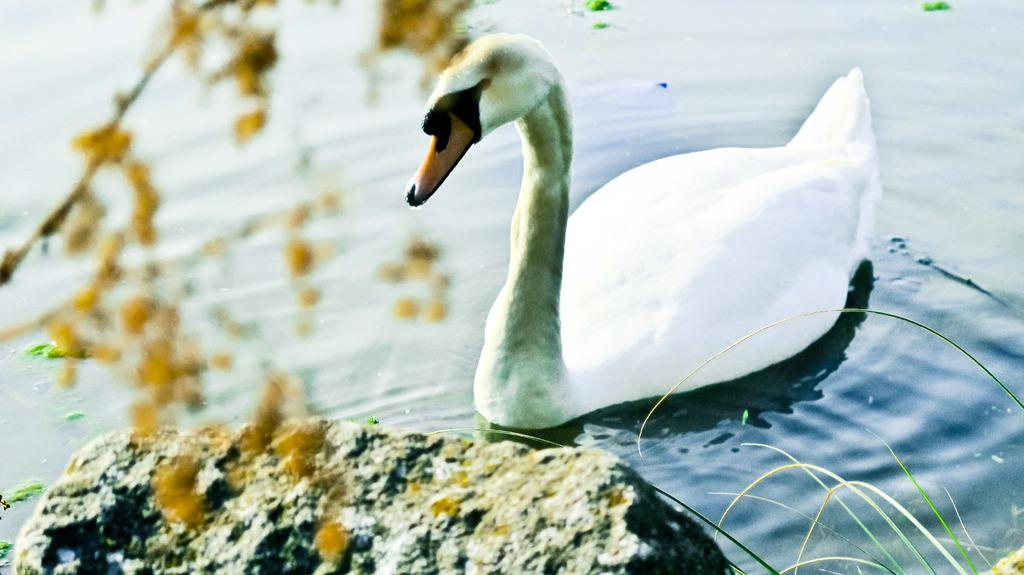What animal can be seen in the water in the image? There is a swan in the water in the image. What is located on the left side of the image? There is a plant on the left side of the image. What is at the bottom of the image? There is a rock at the bottom of the image. What type of vegetation is visible at the bottom of the image? There is grass visible at the bottom of the image. What type of health advice is being given in the image? There is no health advice present in the image; it features a swan in the water, a plant on the left side, a rock at the bottom, and grass visible at the bottom. What type of bird can be seen flying in the image? There is no bird visible in the image, only a swan in the water. 